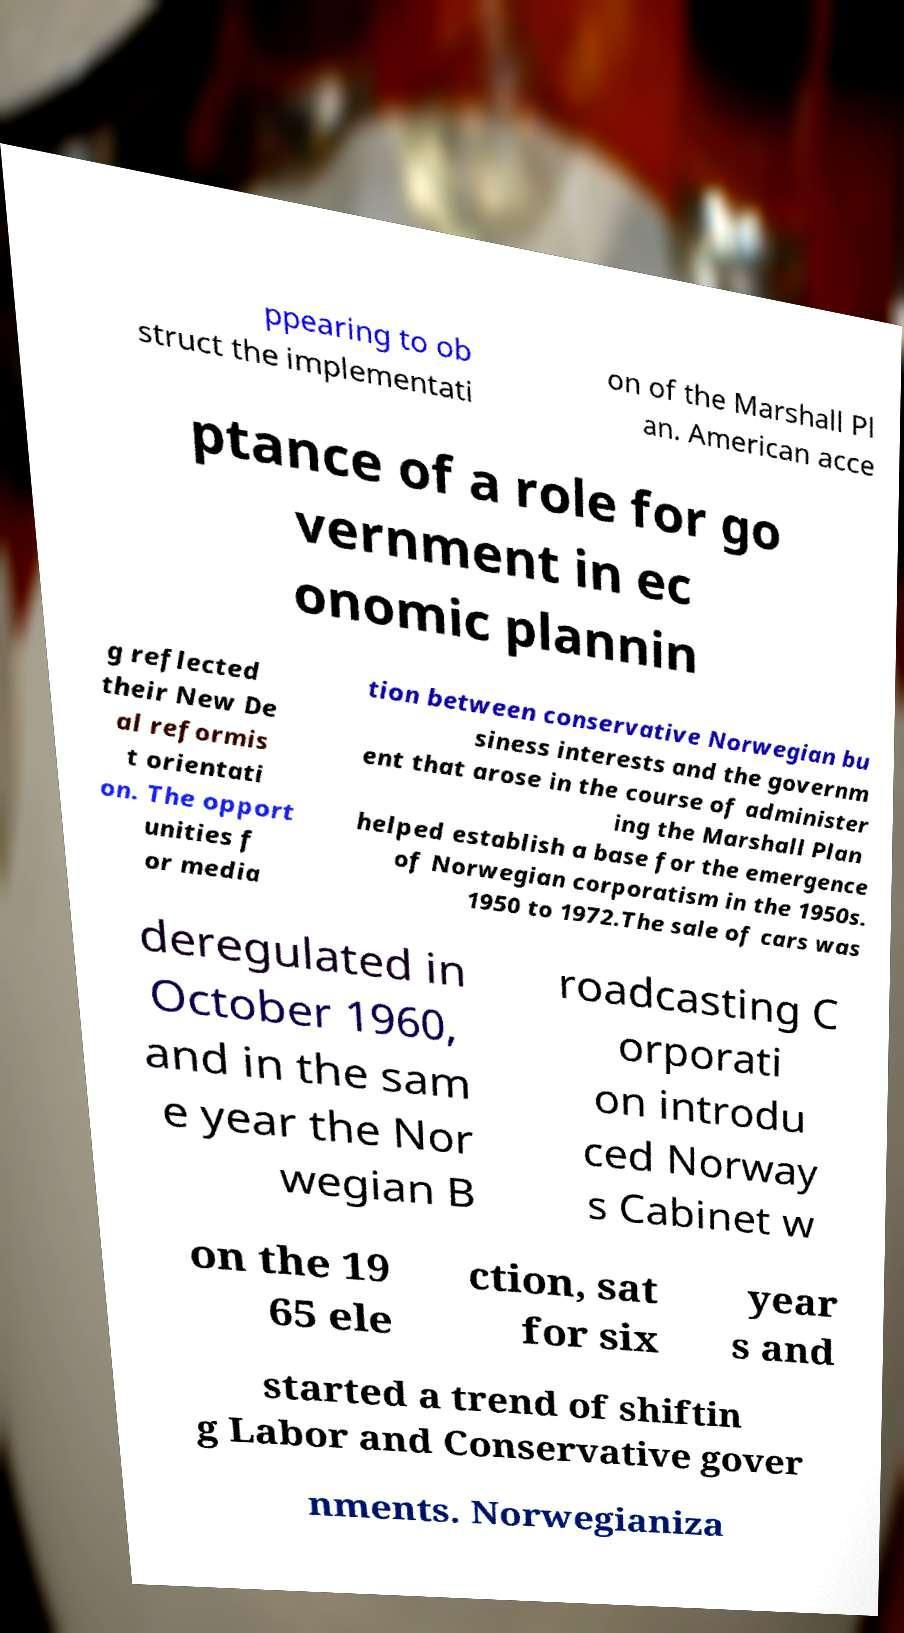Could you extract and type out the text from this image? ppearing to ob struct the implementati on of the Marshall Pl an. American acce ptance of a role for go vernment in ec onomic plannin g reflected their New De al reformis t orientati on. The opport unities f or media tion between conservative Norwegian bu siness interests and the governm ent that arose in the course of administer ing the Marshall Plan helped establish a base for the emergence of Norwegian corporatism in the 1950s. 1950 to 1972.The sale of cars was deregulated in October 1960, and in the sam e year the Nor wegian B roadcasting C orporati on introdu ced Norway s Cabinet w on the 19 65 ele ction, sat for six year s and started a trend of shiftin g Labor and Conservative gover nments. Norwegianiza 